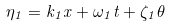Convert formula to latex. <formula><loc_0><loc_0><loc_500><loc_500>\eta _ { 1 } = k _ { 1 } x + \omega _ { 1 } t + \zeta _ { 1 } \theta</formula> 